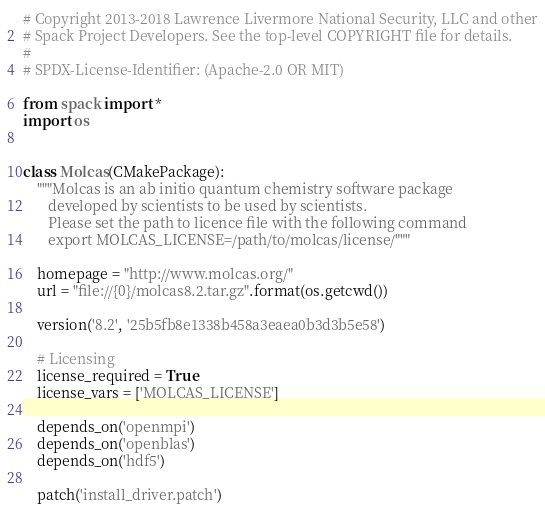<code> <loc_0><loc_0><loc_500><loc_500><_Python_># Copyright 2013-2018 Lawrence Livermore National Security, LLC and other
# Spack Project Developers. See the top-level COPYRIGHT file for details.
#
# SPDX-License-Identifier: (Apache-2.0 OR MIT)

from spack import *
import os


class Molcas(CMakePackage):
    """Molcas is an ab initio quantum chemistry software package
       developed by scientists to be used by scientists.
       Please set the path to licence file with the following command
       export MOLCAS_LICENSE=/path/to/molcas/license/"""

    homepage = "http://www.molcas.org/"
    url = "file://{0}/molcas8.2.tar.gz".format(os.getcwd())

    version('8.2', '25b5fb8e1338b458a3eaea0b3d3b5e58')

    # Licensing
    license_required = True
    license_vars = ['MOLCAS_LICENSE']

    depends_on('openmpi')
    depends_on('openblas')
    depends_on('hdf5')

    patch('install_driver.patch')
</code> 